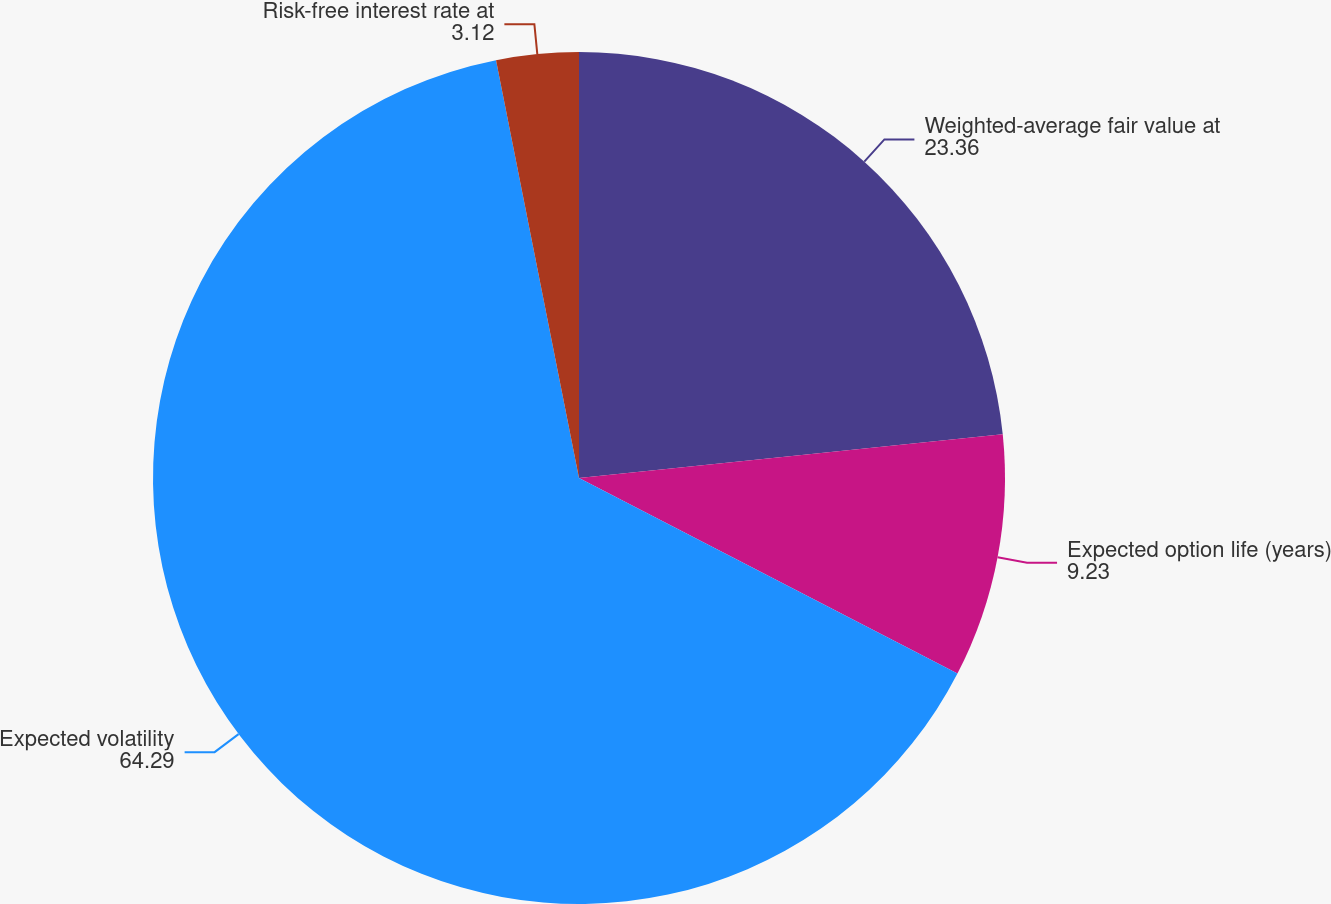<chart> <loc_0><loc_0><loc_500><loc_500><pie_chart><fcel>Weighted-average fair value at<fcel>Expected option life (years)<fcel>Expected volatility<fcel>Risk-free interest rate at<nl><fcel>23.36%<fcel>9.23%<fcel>64.29%<fcel>3.12%<nl></chart> 